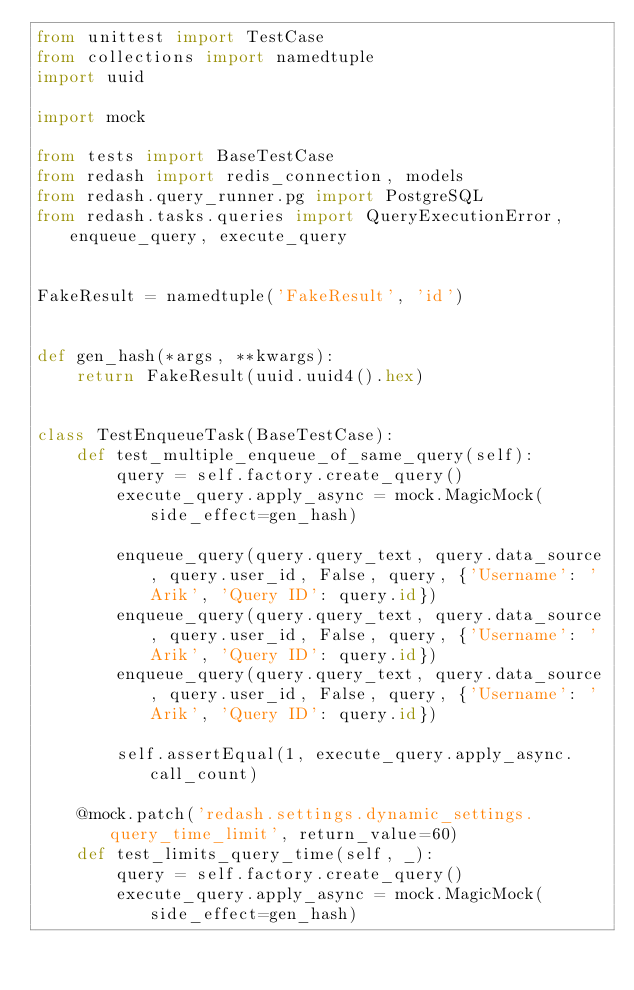<code> <loc_0><loc_0><loc_500><loc_500><_Python_>from unittest import TestCase
from collections import namedtuple
import uuid

import mock

from tests import BaseTestCase
from redash import redis_connection, models
from redash.query_runner.pg import PostgreSQL
from redash.tasks.queries import QueryExecutionError, enqueue_query, execute_query


FakeResult = namedtuple('FakeResult', 'id')


def gen_hash(*args, **kwargs):
    return FakeResult(uuid.uuid4().hex)


class TestEnqueueTask(BaseTestCase):
    def test_multiple_enqueue_of_same_query(self):
        query = self.factory.create_query()
        execute_query.apply_async = mock.MagicMock(side_effect=gen_hash)

        enqueue_query(query.query_text, query.data_source, query.user_id, False, query, {'Username': 'Arik', 'Query ID': query.id})
        enqueue_query(query.query_text, query.data_source, query.user_id, False, query, {'Username': 'Arik', 'Query ID': query.id})
        enqueue_query(query.query_text, query.data_source, query.user_id, False, query, {'Username': 'Arik', 'Query ID': query.id})

        self.assertEqual(1, execute_query.apply_async.call_count)

    @mock.patch('redash.settings.dynamic_settings.query_time_limit', return_value=60)
    def test_limits_query_time(self, _):
        query = self.factory.create_query()
        execute_query.apply_async = mock.MagicMock(side_effect=gen_hash)
</code> 